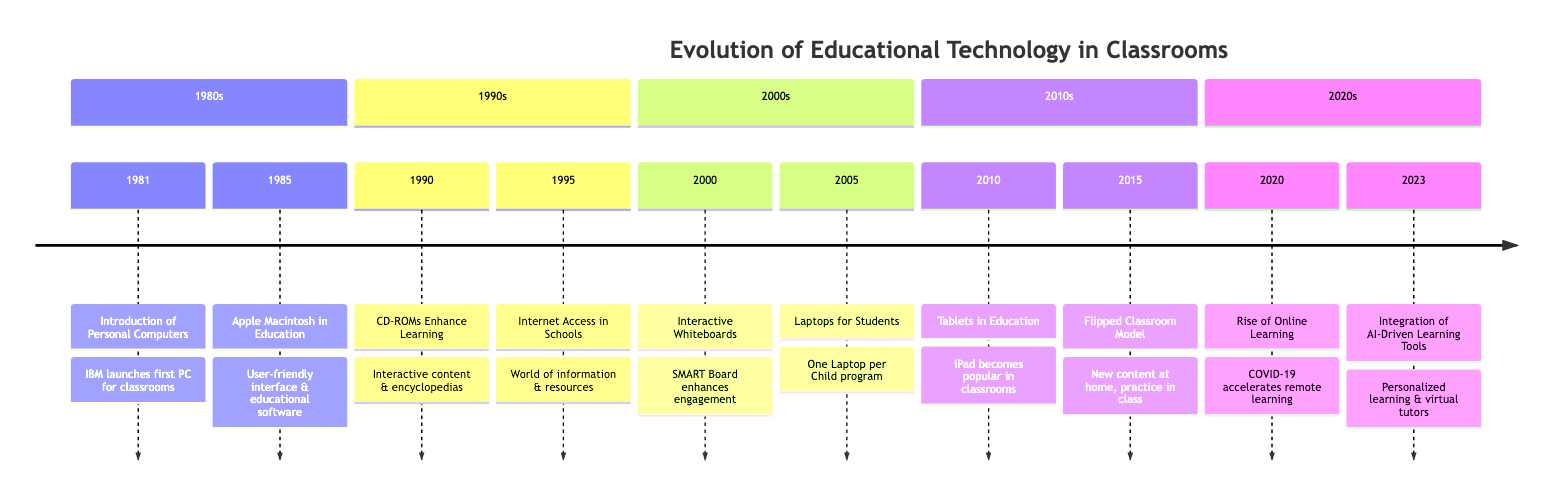What year did the introduction of personal computers occur? The diagram indicates that the introduction of personal computers occurred in the year 1981.
Answer: 1981 What event is associated with the year 1990? According to the timeline, the event associated with the year 1990 is "CD-ROMs Enhance Learning."
Answer: CD-ROMs Enhance Learning What significant event occurred in 2005? The timeline shows that in 2005, the event "Laptops for Students" took place, introduced by the One Laptop per Child program.
Answer: Laptops for Students What technology was introduced in the year 2010? In the year 2010, the diagram states that "Tablets in Education" were introduced, specifically highlighting the popularity of Apple's iPad.
Answer: Tablets in Education Which event marks the beginning of the internet access in schools? The diagram specifies that "Internet Access in Schools" began in 1995, marking the significant development of connecting schools to the internet.
Answer: Internet Access in Schools What is the relationship between the years 2020 and 2023 in the timeline? The years indicate a progression where 2020 marks the "Rise of Online Learning" due to the COVID-19 pandemic, leading to the "Integration of AI-Driven Learning Tools" in 2023.
Answer: Rise of Online Learning leads to Integration of AI-Driven Learning Tools What educational technology trend began to enhance classroom engagement in 2000? According to the timeline, the trend that began in 2000 to enhance classroom engagement is the introduction of "Interactive Whiteboards."
Answer: Interactive Whiteboards How many major events are listed in the timeline? By reviewing the timeline, a total of 10 major events are noted, spanning from 1981 to 2023.
Answer: 10 What was a significant outcome of the scenario in 2015? The 2015 development, described in the timeline, highlights the rise of the "Flipped Classroom Model," which changes how learning occurs in classrooms.
Answer: Flipped Classroom Model What does the timeline suggest as an emerging trend in educational technology by 2023? The timeline suggests that by 2023, the emerging trend in educational technology is the use of "AI-Driven Learning Tools," indicating a move toward personalization in education.
Answer: AI-Driven Learning Tools 